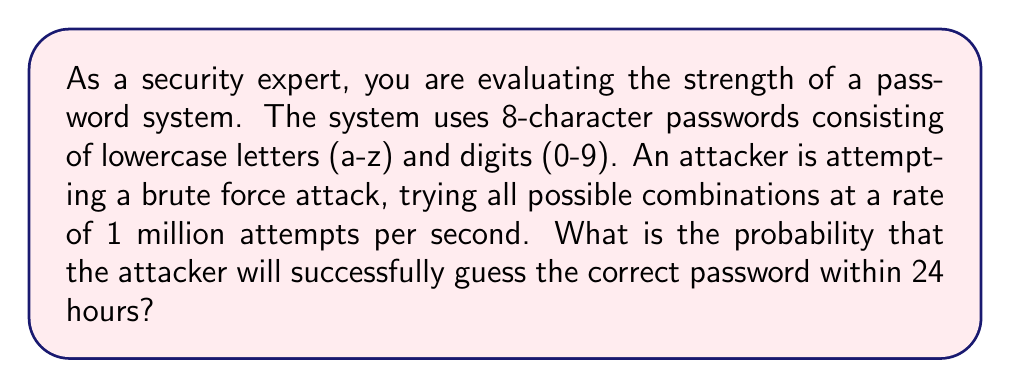What is the answer to this math problem? To solve this problem, we need to follow these steps:

1. Calculate the total number of possible passwords:
   - Characters available: 26 lowercase letters + 10 digits = 36 characters
   - Password length: 8 characters
   - Total combinations: $36^8$

2. Calculate the number of attempts the attacker can make in 24 hours:
   - Attempts per second: 1,000,000
   - Seconds in 24 hours: 24 * 60 * 60 = 86,400
   - Total attempts in 24 hours: 1,000,000 * 86,400

3. Calculate the probability of success:
   - Probability = (Number of attempts / Total possible passwords)

Let's perform the calculations:

1. Total possible passwords:
   $$N = 36^8 = 2,821,109,907,456$$

2. Attempts in 24 hours:
   $$A = 1,000,000 * 86,400 = 86,400,000,000$$

3. Probability of success:
   $$P = \frac{A}{N} = \frac{86,400,000,000}{2,821,109,907,456} \approx 0.0306$$

The probability is approximately 0.0306 or 3.06%.
Answer: The probability that the attacker will successfully guess the correct password within 24 hours is approximately 0.0306 or 3.06%. 